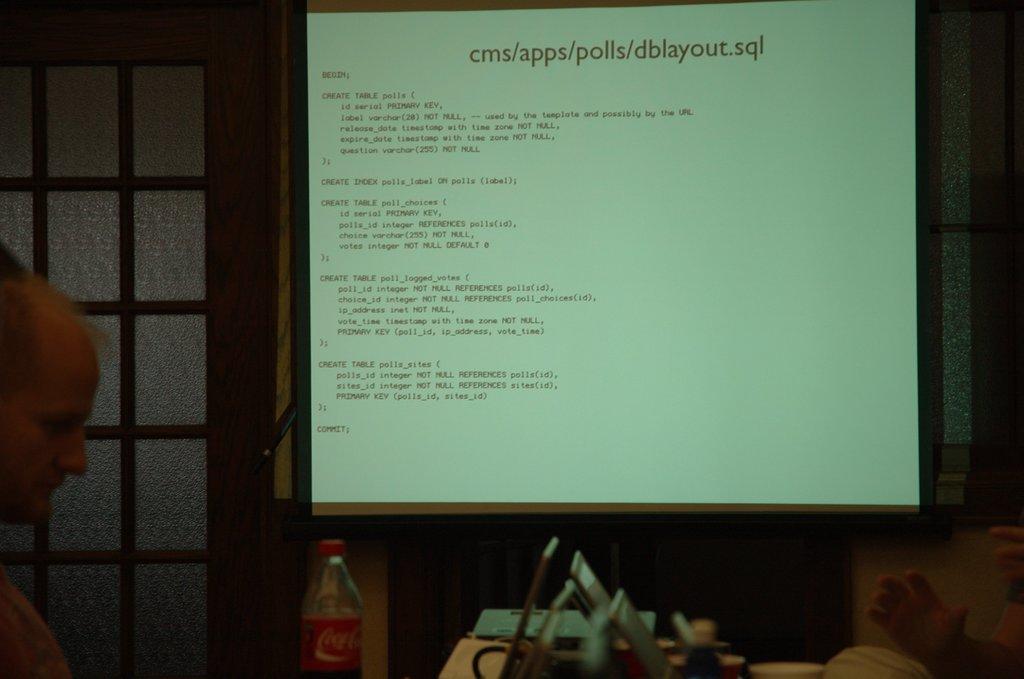Please provide a concise description of this image. There is a screen projecting code and at one corner there is a man standing. 